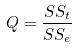Convert formula to latex. <formula><loc_0><loc_0><loc_500><loc_500>Q = \frac { S S _ { t } } { S S _ { e } }</formula> 